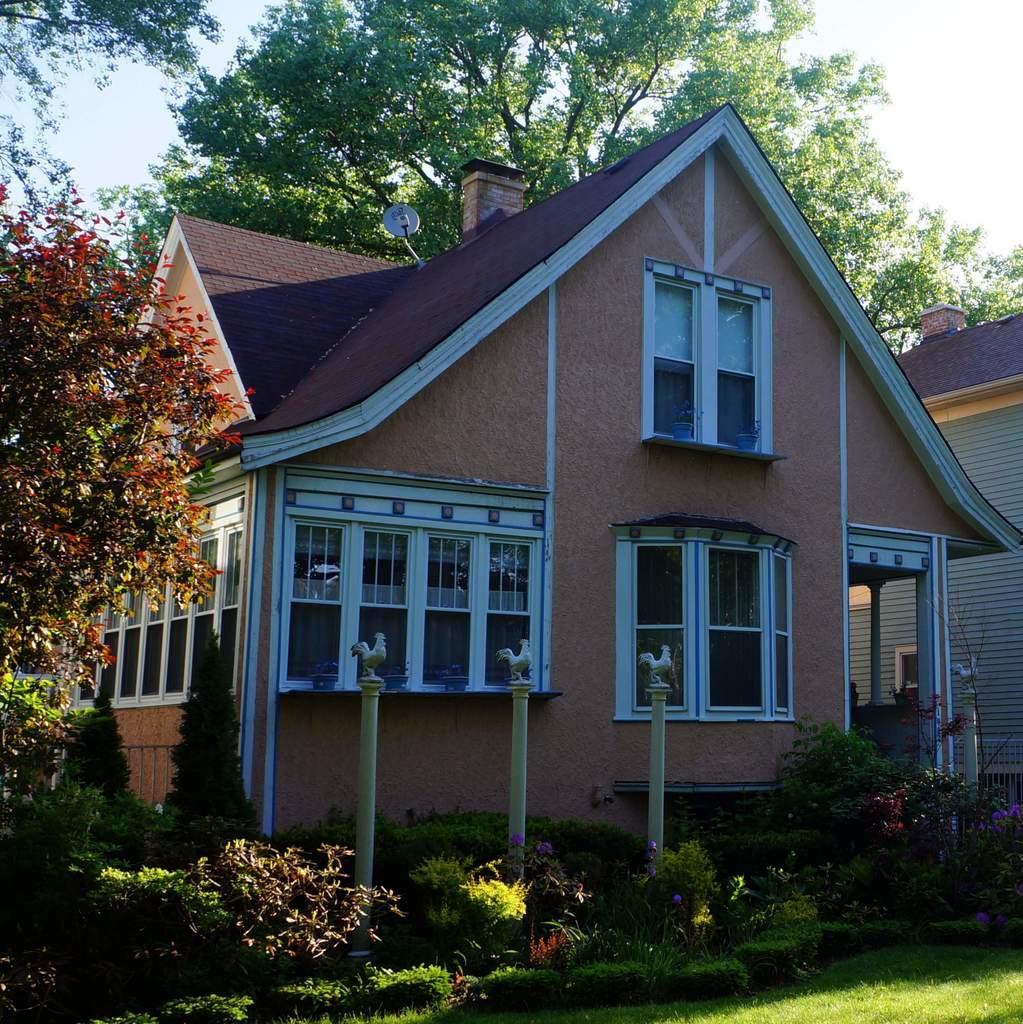Please provide a concise description of this image. To the bottom of the image there is grass on the ground. And also there are plants with poles in the middle. On the poles there are hens statues on it. At the right side of the image there are trees. And in the background there is a house with roof, windows, walls and pillars. Behind the house there are trees. And to the top of the image there is a sky. 